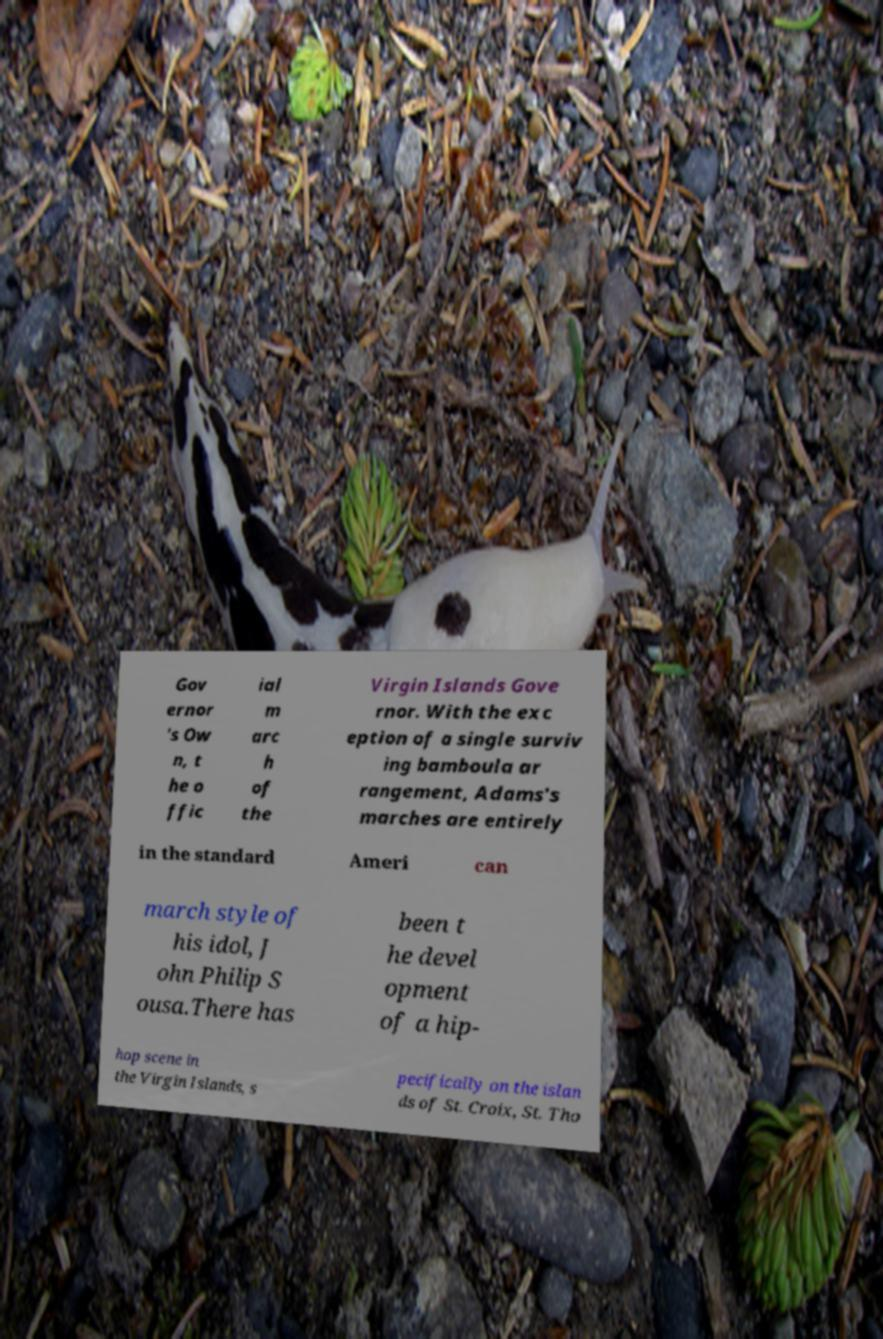There's text embedded in this image that I need extracted. Can you transcribe it verbatim? Gov ernor 's Ow n, t he o ffic ial m arc h of the Virgin Islands Gove rnor. With the exc eption of a single surviv ing bamboula ar rangement, Adams's marches are entirely in the standard Ameri can march style of his idol, J ohn Philip S ousa.There has been t he devel opment of a hip- hop scene in the Virgin Islands, s pecifically on the islan ds of St. Croix, St. Tho 